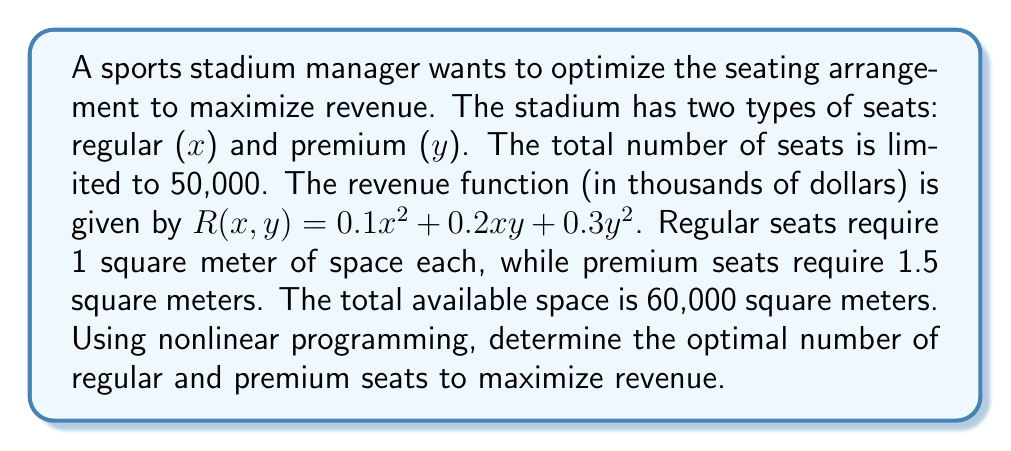Can you answer this question? To solve this problem, we'll use the method of Lagrange multipliers for constrained optimization.

Step 1: Define the objective function and constraints
Objective function: $R(x,y) = 0.1x^2 + 0.2xy + 0.3y^2$
Constraints:
1. $x + y = 50000$ (total seats)
2. $x + 1.5y = 60000$ (space constraint)

Step 2: Form the Lagrangian function
$$L(x,y,\lambda_1,\lambda_2) = 0.1x^2 + 0.2xy + 0.3y^2 - \lambda_1(x + y - 50000) - \lambda_2(x + 1.5y - 60000)$$

Step 3: Calculate partial derivatives and set them to zero
$$\frac{\partial L}{\partial x} = 0.2x + 0.2y - \lambda_1 - \lambda_2 = 0$$
$$\frac{\partial L}{\partial y} = 0.2x + 0.6y - \lambda_1 - 1.5\lambda_2 = 0$$
$$\frac{\partial L}{\partial \lambda_1} = x + y - 50000 = 0$$
$$\frac{\partial L}{\partial \lambda_2} = x + 1.5y - 60000 = 0$$

Step 4: Solve the system of equations
From the last two equations:
$$y = 50000 - x$$
$$y = 40000 - \frac{2}{3}x$$

Equating these:
$$50000 - x = 40000 - \frac{2}{3}x$$
$$10000 = \frac{1}{3}x$$
$$x = 30000$$

Substituting back:
$$y = 50000 - 30000 = 20000$$

Step 5: Verify the solution satisfies all constraints
$30000 + 20000 = 50000$ (total seats constraint satisfied)
$30000 + 1.5(20000) = 60000$ (space constraint satisfied)

Step 6: Calculate the maximum revenue
$$R(30000, 20000) = 0.1(30000)^2 + 0.2(30000)(20000) + 0.3(20000)^2$$
$$= 90,000,000 + 120,000,000 + 120,000,000 = 330,000,000$$

The maximum revenue is $330 million.
Answer: 30,000 regular seats, 20,000 premium seats; $330 million revenue 